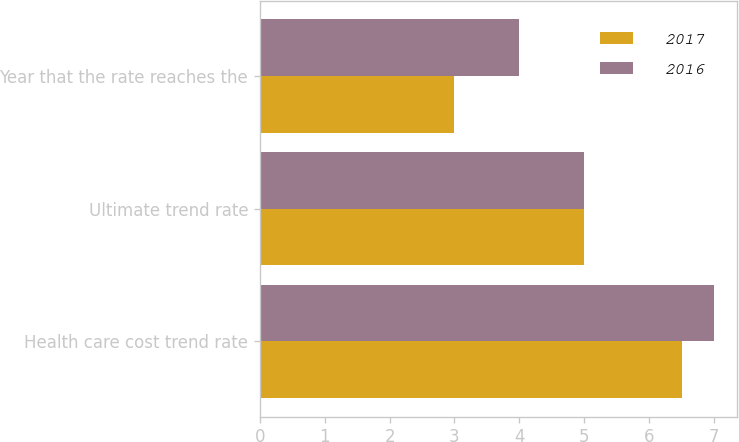Convert chart. <chart><loc_0><loc_0><loc_500><loc_500><stacked_bar_chart><ecel><fcel>Health care cost trend rate<fcel>Ultimate trend rate<fcel>Year that the rate reaches the<nl><fcel>2017<fcel>6.5<fcel>5<fcel>3<nl><fcel>2016<fcel>7<fcel>5<fcel>4<nl></chart> 